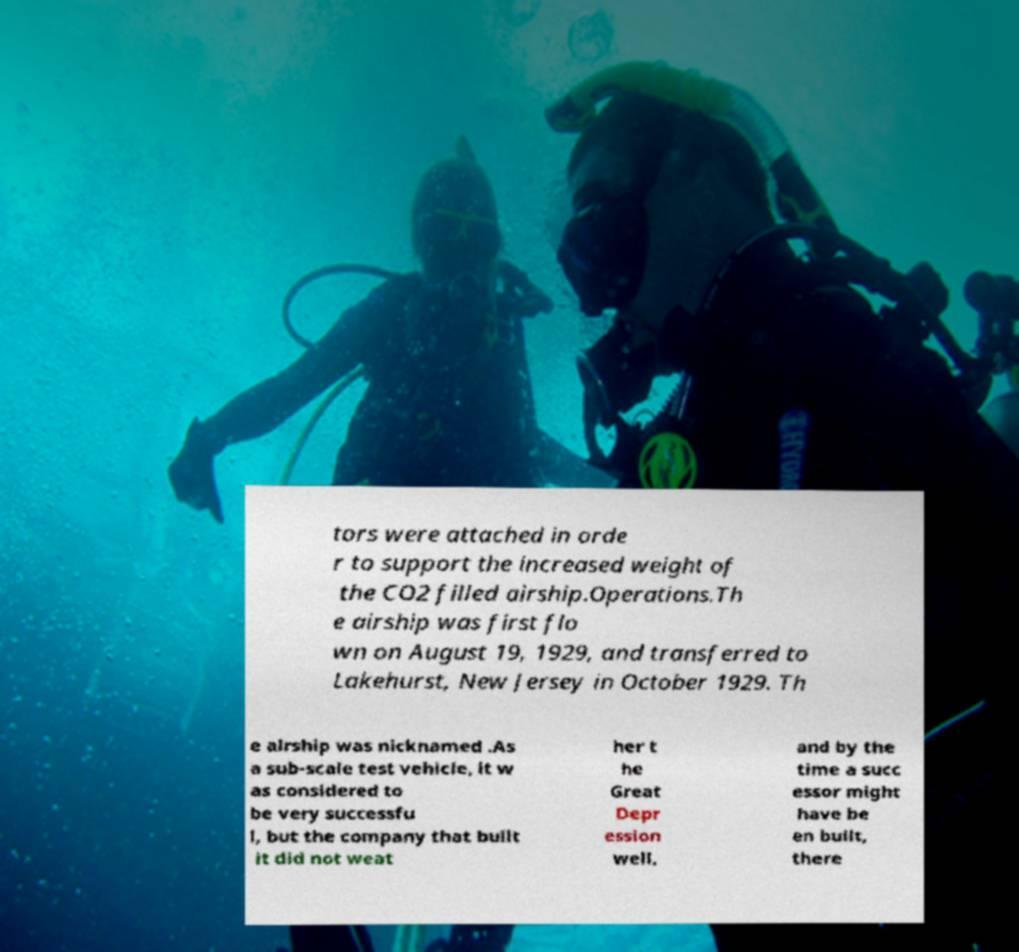Could you extract and type out the text from this image? tors were attached in orde r to support the increased weight of the CO2 filled airship.Operations.Th e airship was first flo wn on August 19, 1929, and transferred to Lakehurst, New Jersey in October 1929. Th e airship was nicknamed .As a sub-scale test vehicle, it w as considered to be very successfu l, but the company that built it did not weat her t he Great Depr ession well, and by the time a succ essor might have be en built, there 